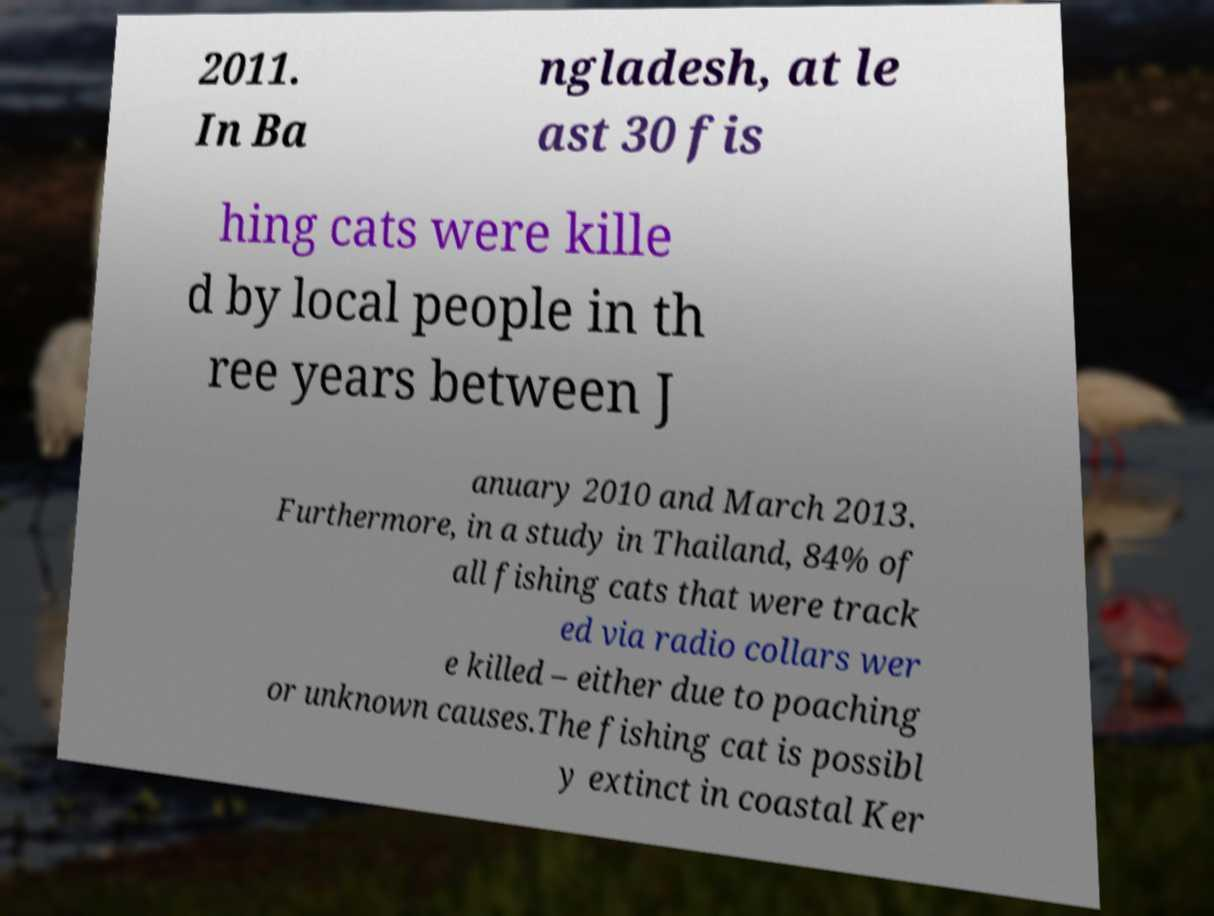Could you extract and type out the text from this image? 2011. In Ba ngladesh, at le ast 30 fis hing cats were kille d by local people in th ree years between J anuary 2010 and March 2013. Furthermore, in a study in Thailand, 84% of all fishing cats that were track ed via radio collars wer e killed – either due to poaching or unknown causes.The fishing cat is possibl y extinct in coastal Ker 